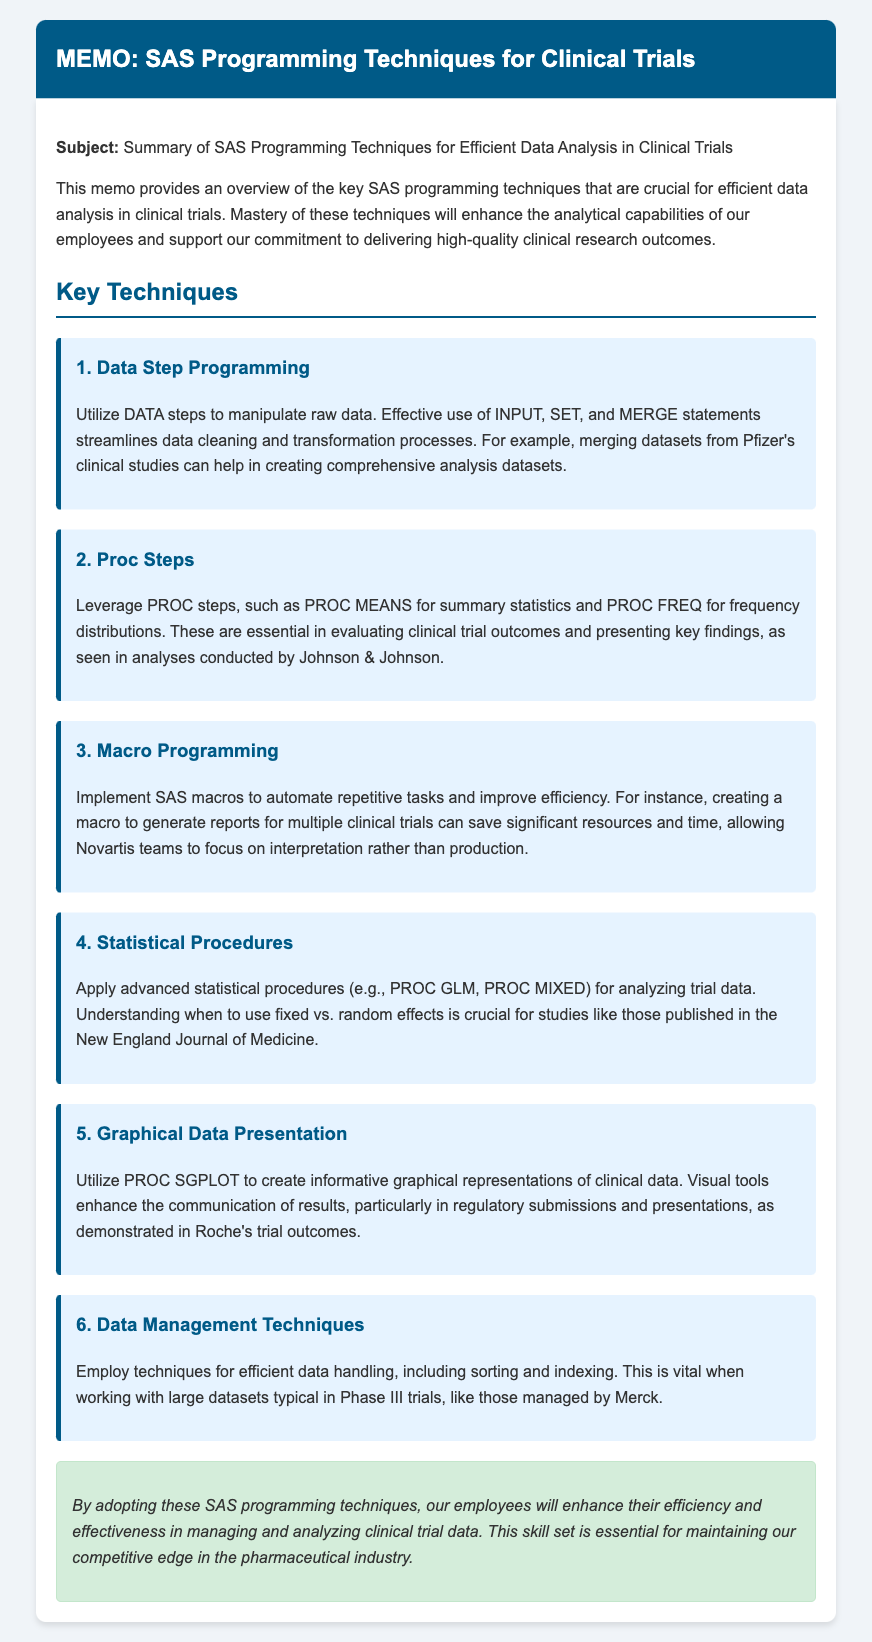What is the subject of the memo? The subject is clearly stated at the beginning of the memo, specifically focusing on SAS programming techniques for data analysis in clinical trials.
Answer: Summary of SAS Programming Techniques for Efficient Data Analysis in Clinical Trials How many key techniques are outlined in the memo? The memo lists a total of six key techniques for SAS programming to enhance data analysis in clinical trials.
Answer: 6 What technique involves automating repetitive tasks? The description indicates that SAS macros are specifically mentioned for the automation of repetitive tasks within the programming context.
Answer: Macro Programming Which company is cited for creating comprehensive analysis datasets through merging? The memo gives an example of Pfizer in the context of merging datasets related to clinical studies.
Answer: Pfizer What is a key statistical procedure mentioned for analyzing trial data? Among the statistical procedures listed, PROC GLM is highlighted as a significant procedure for analysis in clinical trials.
Answer: PROC GLM What type of graphical representation technique is recommended in the memo? The memo recommends utilizing PROC SGPLOT for creating informative graphical representations of clinical data.
Answer: PROC SGPLOT Which company is noted for managing large datasets in Phase III trials? The memo references Merck in relation to the management of large datasets during Phase III trials.
Answer: Merck What is the purpose of the memo according to the document? The document states that the overall purpose is to enhance analytical capabilities and support high-quality clinical research outcomes.
Answer: Enhance analytical capabilities and support high-quality clinical research outcomes 